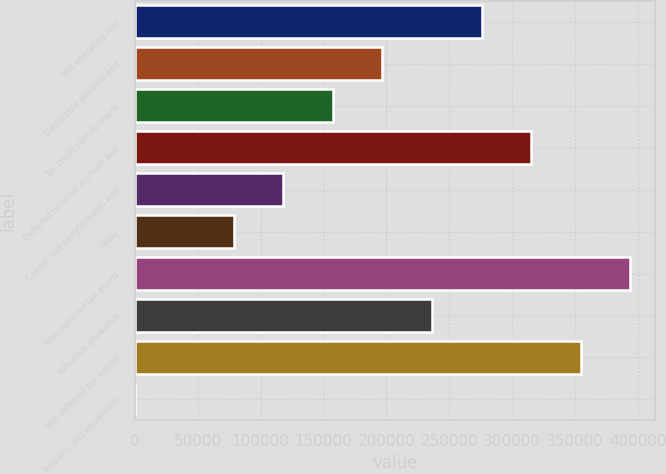<chart> <loc_0><loc_0><loc_500><loc_500><bar_chart><fcel>Net operating loss<fcel>Deductible goodwill and<fcel>Tax credit carryforwards<fcel>Deferred revenue accruals and<fcel>Capital loss carryforwards and<fcel>Other<fcel>Total deferred tax assets<fcel>Valuation allowance<fcel>Net deferred tax assets<fcel>Property and equipment<nl><fcel>275625<fcel>196887<fcel>157518<fcel>314994<fcel>118149<fcel>78780<fcel>393732<fcel>236256<fcel>354363<fcel>42<nl></chart> 